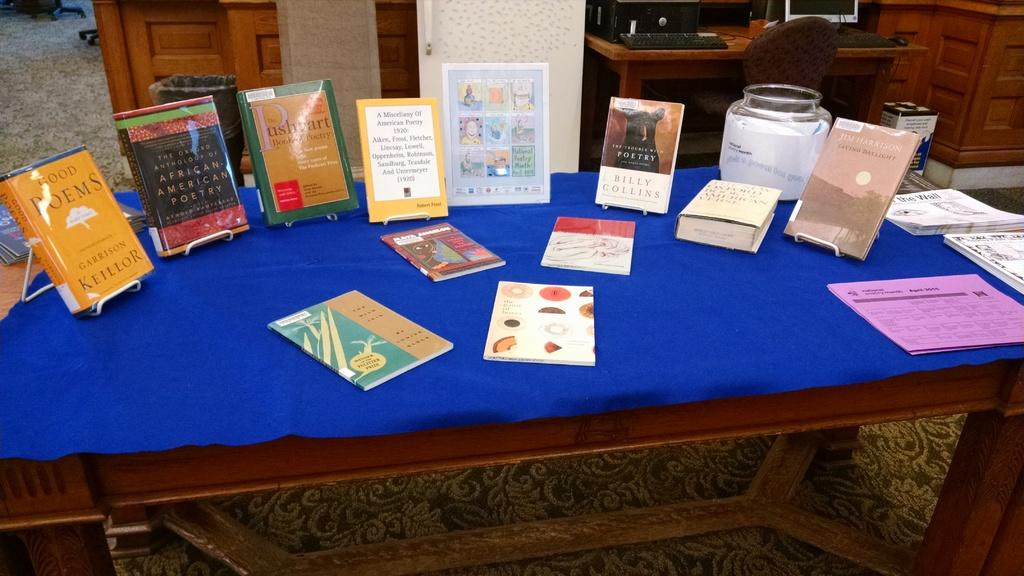What type of furniture is present in the image? There is a table in the image. What items can be seen on the first table? There are books on the table. What is the arrangement of the tables in the image? There is another table behind the first table. What type of equipment is on the second table? There is a keyboard and a mouse on the second table. What route does the umbrella take to reach the table in the image? There is no umbrella present in the image, so it cannot take any route to reach the table. 